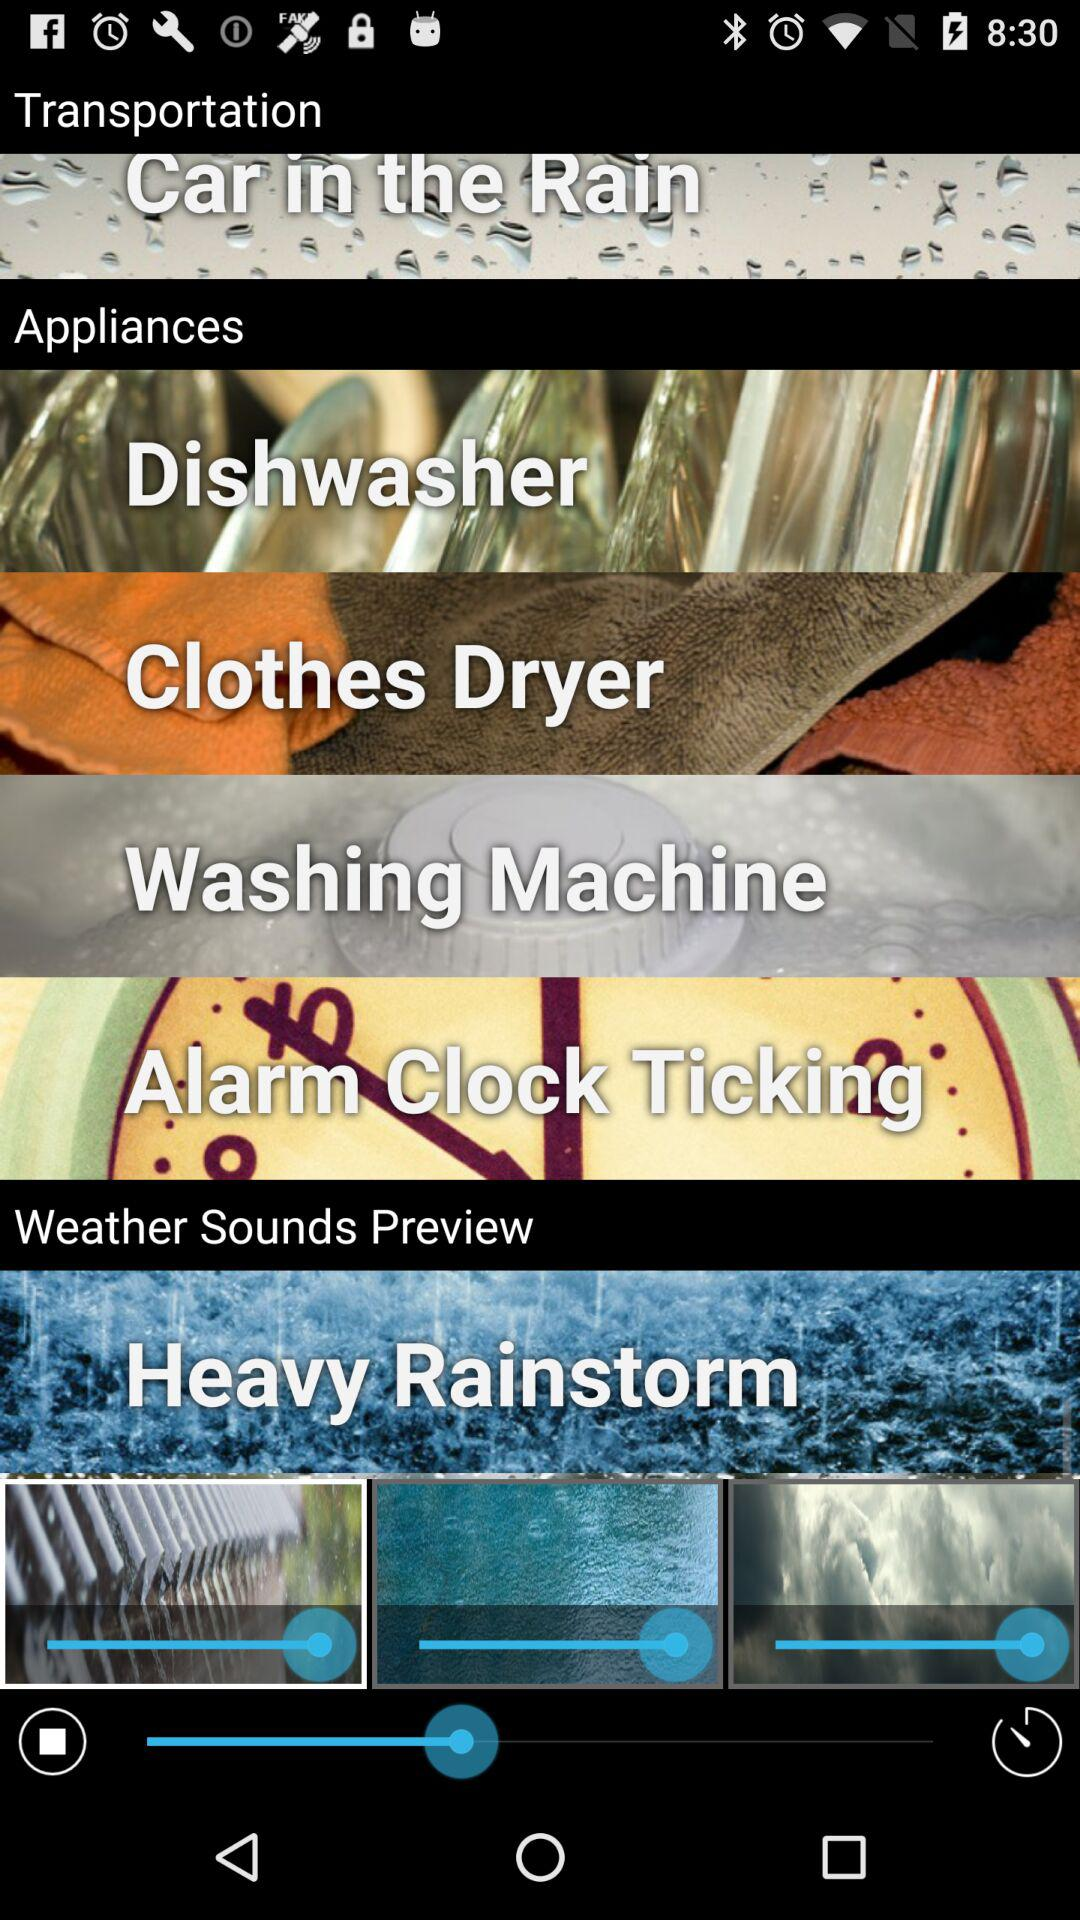How many more items are in the Appliances section than the Weather Sounds Preview section?
Answer the question using a single word or phrase. 3 